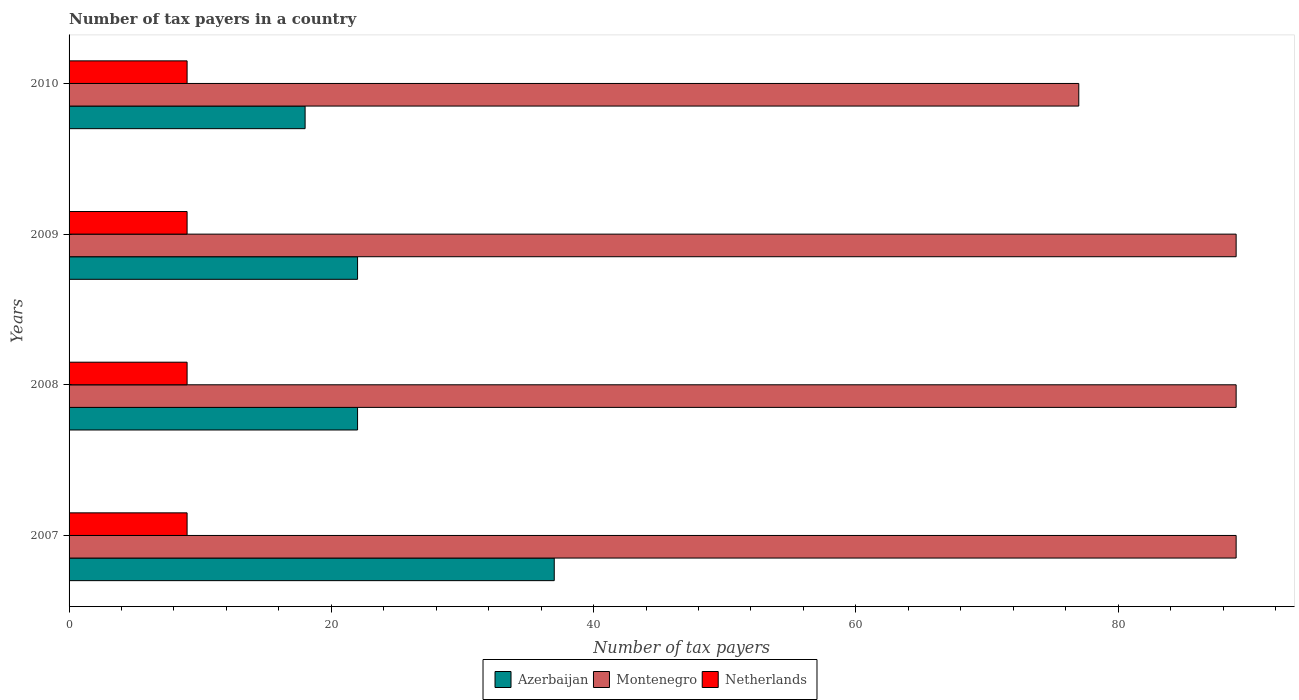How many different coloured bars are there?
Ensure brevity in your answer.  3. Are the number of bars per tick equal to the number of legend labels?
Keep it short and to the point. Yes. How many bars are there on the 4th tick from the top?
Provide a short and direct response. 3. How many bars are there on the 2nd tick from the bottom?
Your answer should be very brief. 3. In how many cases, is the number of bars for a given year not equal to the number of legend labels?
Make the answer very short. 0. What is the number of tax payers in in Netherlands in 2009?
Your answer should be very brief. 9. Across all years, what is the maximum number of tax payers in in Azerbaijan?
Offer a very short reply. 37. Across all years, what is the minimum number of tax payers in in Netherlands?
Provide a short and direct response. 9. In which year was the number of tax payers in in Montenegro minimum?
Give a very brief answer. 2010. What is the total number of tax payers in in Netherlands in the graph?
Offer a very short reply. 36. What is the difference between the number of tax payers in in Netherlands in 2008 and that in 2010?
Ensure brevity in your answer.  0. What is the difference between the number of tax payers in in Netherlands in 2008 and the number of tax payers in in Montenegro in 2007?
Your response must be concise. -80. What is the average number of tax payers in in Montenegro per year?
Offer a very short reply. 86. In how many years, is the number of tax payers in in Netherlands greater than 64 ?
Keep it short and to the point. 0. What is the difference between the highest and the second highest number of tax payers in in Montenegro?
Keep it short and to the point. 0. What is the difference between the highest and the lowest number of tax payers in in Azerbaijan?
Make the answer very short. 19. Is the sum of the number of tax payers in in Montenegro in 2007 and 2009 greater than the maximum number of tax payers in in Netherlands across all years?
Provide a short and direct response. Yes. What does the 3rd bar from the top in 2008 represents?
Provide a short and direct response. Azerbaijan. Is it the case that in every year, the sum of the number of tax payers in in Netherlands and number of tax payers in in Montenegro is greater than the number of tax payers in in Azerbaijan?
Offer a very short reply. Yes. How many bars are there?
Ensure brevity in your answer.  12. Are all the bars in the graph horizontal?
Your answer should be compact. Yes. What is the difference between two consecutive major ticks on the X-axis?
Keep it short and to the point. 20. Are the values on the major ticks of X-axis written in scientific E-notation?
Give a very brief answer. No. Does the graph contain any zero values?
Provide a short and direct response. No. What is the title of the graph?
Give a very brief answer. Number of tax payers in a country. What is the label or title of the X-axis?
Give a very brief answer. Number of tax payers. What is the Number of tax payers in Azerbaijan in 2007?
Offer a terse response. 37. What is the Number of tax payers in Montenegro in 2007?
Keep it short and to the point. 89. What is the Number of tax payers of Netherlands in 2007?
Keep it short and to the point. 9. What is the Number of tax payers of Montenegro in 2008?
Offer a very short reply. 89. What is the Number of tax payers in Montenegro in 2009?
Provide a succinct answer. 89. What is the Number of tax payers in Montenegro in 2010?
Provide a succinct answer. 77. What is the Number of tax payers of Netherlands in 2010?
Your answer should be compact. 9. Across all years, what is the maximum Number of tax payers in Azerbaijan?
Ensure brevity in your answer.  37. Across all years, what is the maximum Number of tax payers of Montenegro?
Give a very brief answer. 89. Across all years, what is the maximum Number of tax payers in Netherlands?
Your answer should be compact. 9. Across all years, what is the minimum Number of tax payers of Azerbaijan?
Your answer should be very brief. 18. Across all years, what is the minimum Number of tax payers of Netherlands?
Make the answer very short. 9. What is the total Number of tax payers of Montenegro in the graph?
Your response must be concise. 344. What is the difference between the Number of tax payers in Montenegro in 2007 and that in 2008?
Your answer should be very brief. 0. What is the difference between the Number of tax payers of Montenegro in 2007 and that in 2009?
Your response must be concise. 0. What is the difference between the Number of tax payers of Netherlands in 2007 and that in 2009?
Make the answer very short. 0. What is the difference between the Number of tax payers of Montenegro in 2007 and that in 2010?
Your answer should be very brief. 12. What is the difference between the Number of tax payers of Azerbaijan in 2008 and that in 2009?
Your answer should be compact. 0. What is the difference between the Number of tax payers of Montenegro in 2008 and that in 2009?
Your answer should be compact. 0. What is the difference between the Number of tax payers in Azerbaijan in 2008 and that in 2010?
Offer a terse response. 4. What is the difference between the Number of tax payers of Montenegro in 2008 and that in 2010?
Offer a terse response. 12. What is the difference between the Number of tax payers in Netherlands in 2008 and that in 2010?
Offer a very short reply. 0. What is the difference between the Number of tax payers of Montenegro in 2009 and that in 2010?
Offer a very short reply. 12. What is the difference between the Number of tax payers of Netherlands in 2009 and that in 2010?
Offer a terse response. 0. What is the difference between the Number of tax payers of Azerbaijan in 2007 and the Number of tax payers of Montenegro in 2008?
Give a very brief answer. -52. What is the difference between the Number of tax payers of Azerbaijan in 2007 and the Number of tax payers of Montenegro in 2009?
Make the answer very short. -52. What is the difference between the Number of tax payers of Azerbaijan in 2007 and the Number of tax payers of Netherlands in 2009?
Your response must be concise. 28. What is the difference between the Number of tax payers in Montenegro in 2007 and the Number of tax payers in Netherlands in 2009?
Give a very brief answer. 80. What is the difference between the Number of tax payers of Azerbaijan in 2008 and the Number of tax payers of Montenegro in 2009?
Your response must be concise. -67. What is the difference between the Number of tax payers of Azerbaijan in 2008 and the Number of tax payers of Netherlands in 2009?
Make the answer very short. 13. What is the difference between the Number of tax payers in Azerbaijan in 2008 and the Number of tax payers in Montenegro in 2010?
Your answer should be compact. -55. What is the difference between the Number of tax payers in Montenegro in 2008 and the Number of tax payers in Netherlands in 2010?
Your response must be concise. 80. What is the difference between the Number of tax payers of Azerbaijan in 2009 and the Number of tax payers of Montenegro in 2010?
Offer a terse response. -55. What is the difference between the Number of tax payers in Azerbaijan in 2009 and the Number of tax payers in Netherlands in 2010?
Provide a succinct answer. 13. What is the difference between the Number of tax payers in Montenegro in 2009 and the Number of tax payers in Netherlands in 2010?
Keep it short and to the point. 80. What is the average Number of tax payers in Azerbaijan per year?
Your answer should be compact. 24.75. What is the average Number of tax payers of Netherlands per year?
Your answer should be very brief. 9. In the year 2007, what is the difference between the Number of tax payers in Azerbaijan and Number of tax payers in Montenegro?
Make the answer very short. -52. In the year 2007, what is the difference between the Number of tax payers in Montenegro and Number of tax payers in Netherlands?
Offer a very short reply. 80. In the year 2008, what is the difference between the Number of tax payers of Azerbaijan and Number of tax payers of Montenegro?
Give a very brief answer. -67. In the year 2008, what is the difference between the Number of tax payers in Montenegro and Number of tax payers in Netherlands?
Provide a succinct answer. 80. In the year 2009, what is the difference between the Number of tax payers of Azerbaijan and Number of tax payers of Montenegro?
Your answer should be very brief. -67. In the year 2009, what is the difference between the Number of tax payers in Azerbaijan and Number of tax payers in Netherlands?
Make the answer very short. 13. In the year 2010, what is the difference between the Number of tax payers in Azerbaijan and Number of tax payers in Montenegro?
Make the answer very short. -59. What is the ratio of the Number of tax payers in Azerbaijan in 2007 to that in 2008?
Your response must be concise. 1.68. What is the ratio of the Number of tax payers of Azerbaijan in 2007 to that in 2009?
Provide a succinct answer. 1.68. What is the ratio of the Number of tax payers in Montenegro in 2007 to that in 2009?
Give a very brief answer. 1. What is the ratio of the Number of tax payers in Netherlands in 2007 to that in 2009?
Provide a succinct answer. 1. What is the ratio of the Number of tax payers in Azerbaijan in 2007 to that in 2010?
Provide a short and direct response. 2.06. What is the ratio of the Number of tax payers in Montenegro in 2007 to that in 2010?
Offer a terse response. 1.16. What is the ratio of the Number of tax payers of Netherlands in 2007 to that in 2010?
Your answer should be compact. 1. What is the ratio of the Number of tax payers of Azerbaijan in 2008 to that in 2010?
Offer a terse response. 1.22. What is the ratio of the Number of tax payers in Montenegro in 2008 to that in 2010?
Provide a succinct answer. 1.16. What is the ratio of the Number of tax payers of Azerbaijan in 2009 to that in 2010?
Keep it short and to the point. 1.22. What is the ratio of the Number of tax payers in Montenegro in 2009 to that in 2010?
Your answer should be very brief. 1.16. What is the ratio of the Number of tax payers in Netherlands in 2009 to that in 2010?
Your response must be concise. 1. What is the difference between the highest and the second highest Number of tax payers in Netherlands?
Your answer should be very brief. 0. What is the difference between the highest and the lowest Number of tax payers in Azerbaijan?
Your answer should be compact. 19. What is the difference between the highest and the lowest Number of tax payers of Montenegro?
Offer a terse response. 12. 